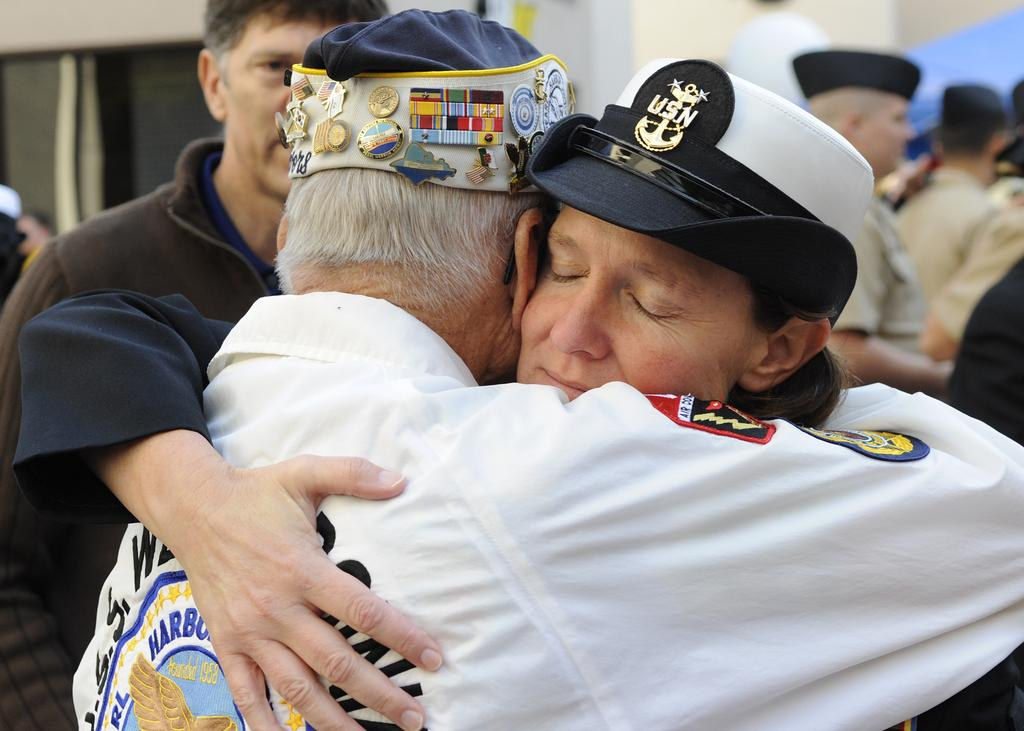What can be seen in the image? There are people standing in the image. What are the people wearing on their heads? The people are wearing caps. Are there any distinguishing features on the caps? Yes, there are badges on the caps. Can you tell me how many frogs are sitting on the people's shoulders in the image? There are no frogs present in the image; the people are wearing caps with badges. 